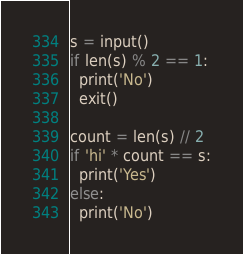Convert code to text. <code><loc_0><loc_0><loc_500><loc_500><_Python_>s = input()
if len(s) % 2 == 1:
  print('No')
  exit()

count = len(s) // 2
if 'hi' * count == s:
  print('Yes')
else:
  print('No')
</code> 